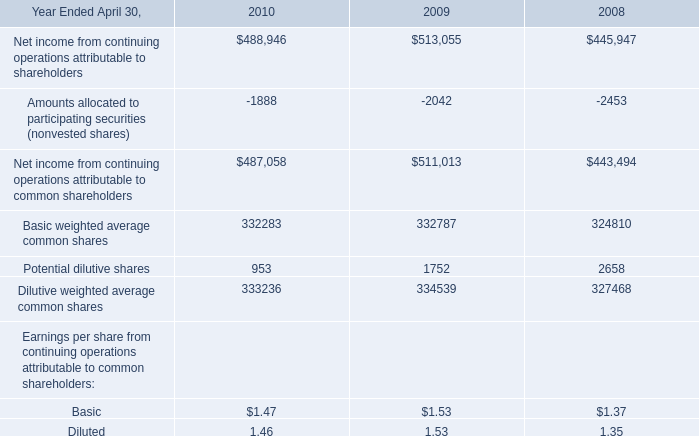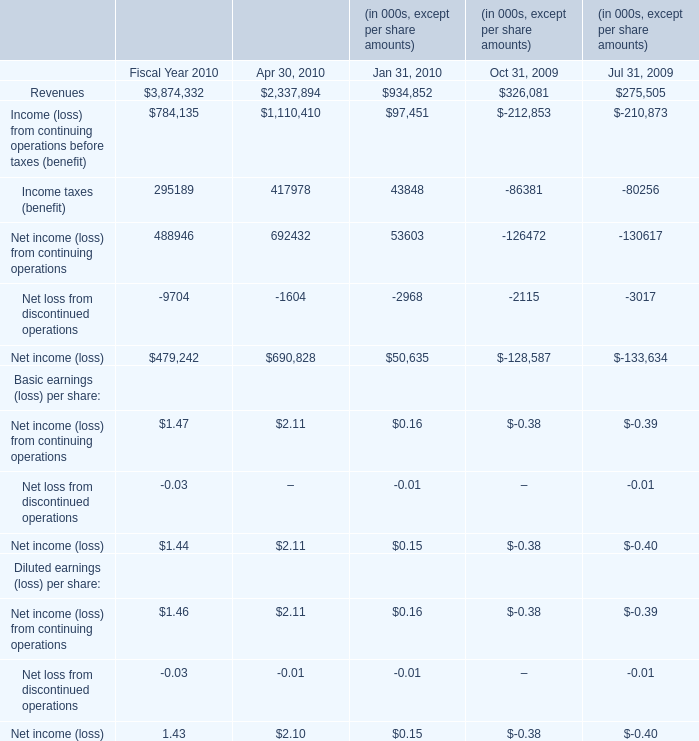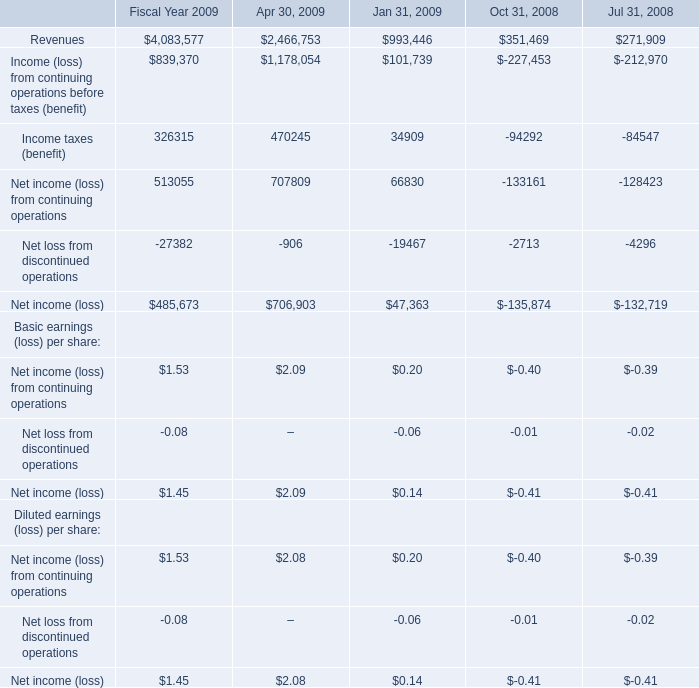What is the total value of Revenues, Income (loss) from continuing operations before taxes (benefit), Income taxes (benefit) and Net income (loss) from continuing operations in 2010 for Fiscal Year? 
Computations: (((3874332 + 784135) + 295189) + 488946)
Answer: 5442602.0. 